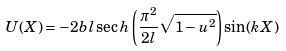<formula> <loc_0><loc_0><loc_500><loc_500>U ( X ) = - 2 b l \sec h \left ( \frac { \pi ^ { 2 } } { 2 l } \sqrt { 1 - u ^ { 2 } } \right ) \sin ( k X )</formula> 